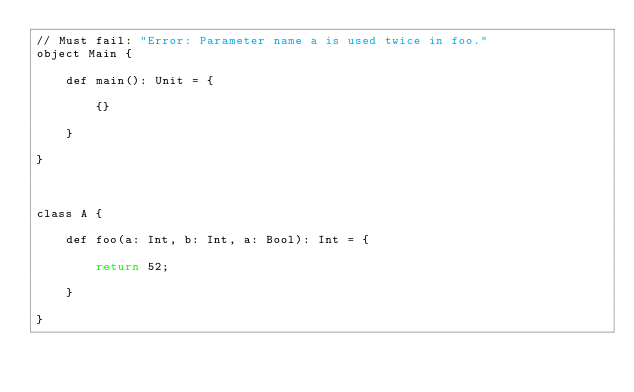<code> <loc_0><loc_0><loc_500><loc_500><_Bash_>// Must fail: "Error: Parameter name a is used twice in foo."
object Main {

    def main(): Unit = {

        {}

    }

}



class A {

    def foo(a: Int, b: Int, a: Bool): Int = {

        return 52;

    }

}</code> 